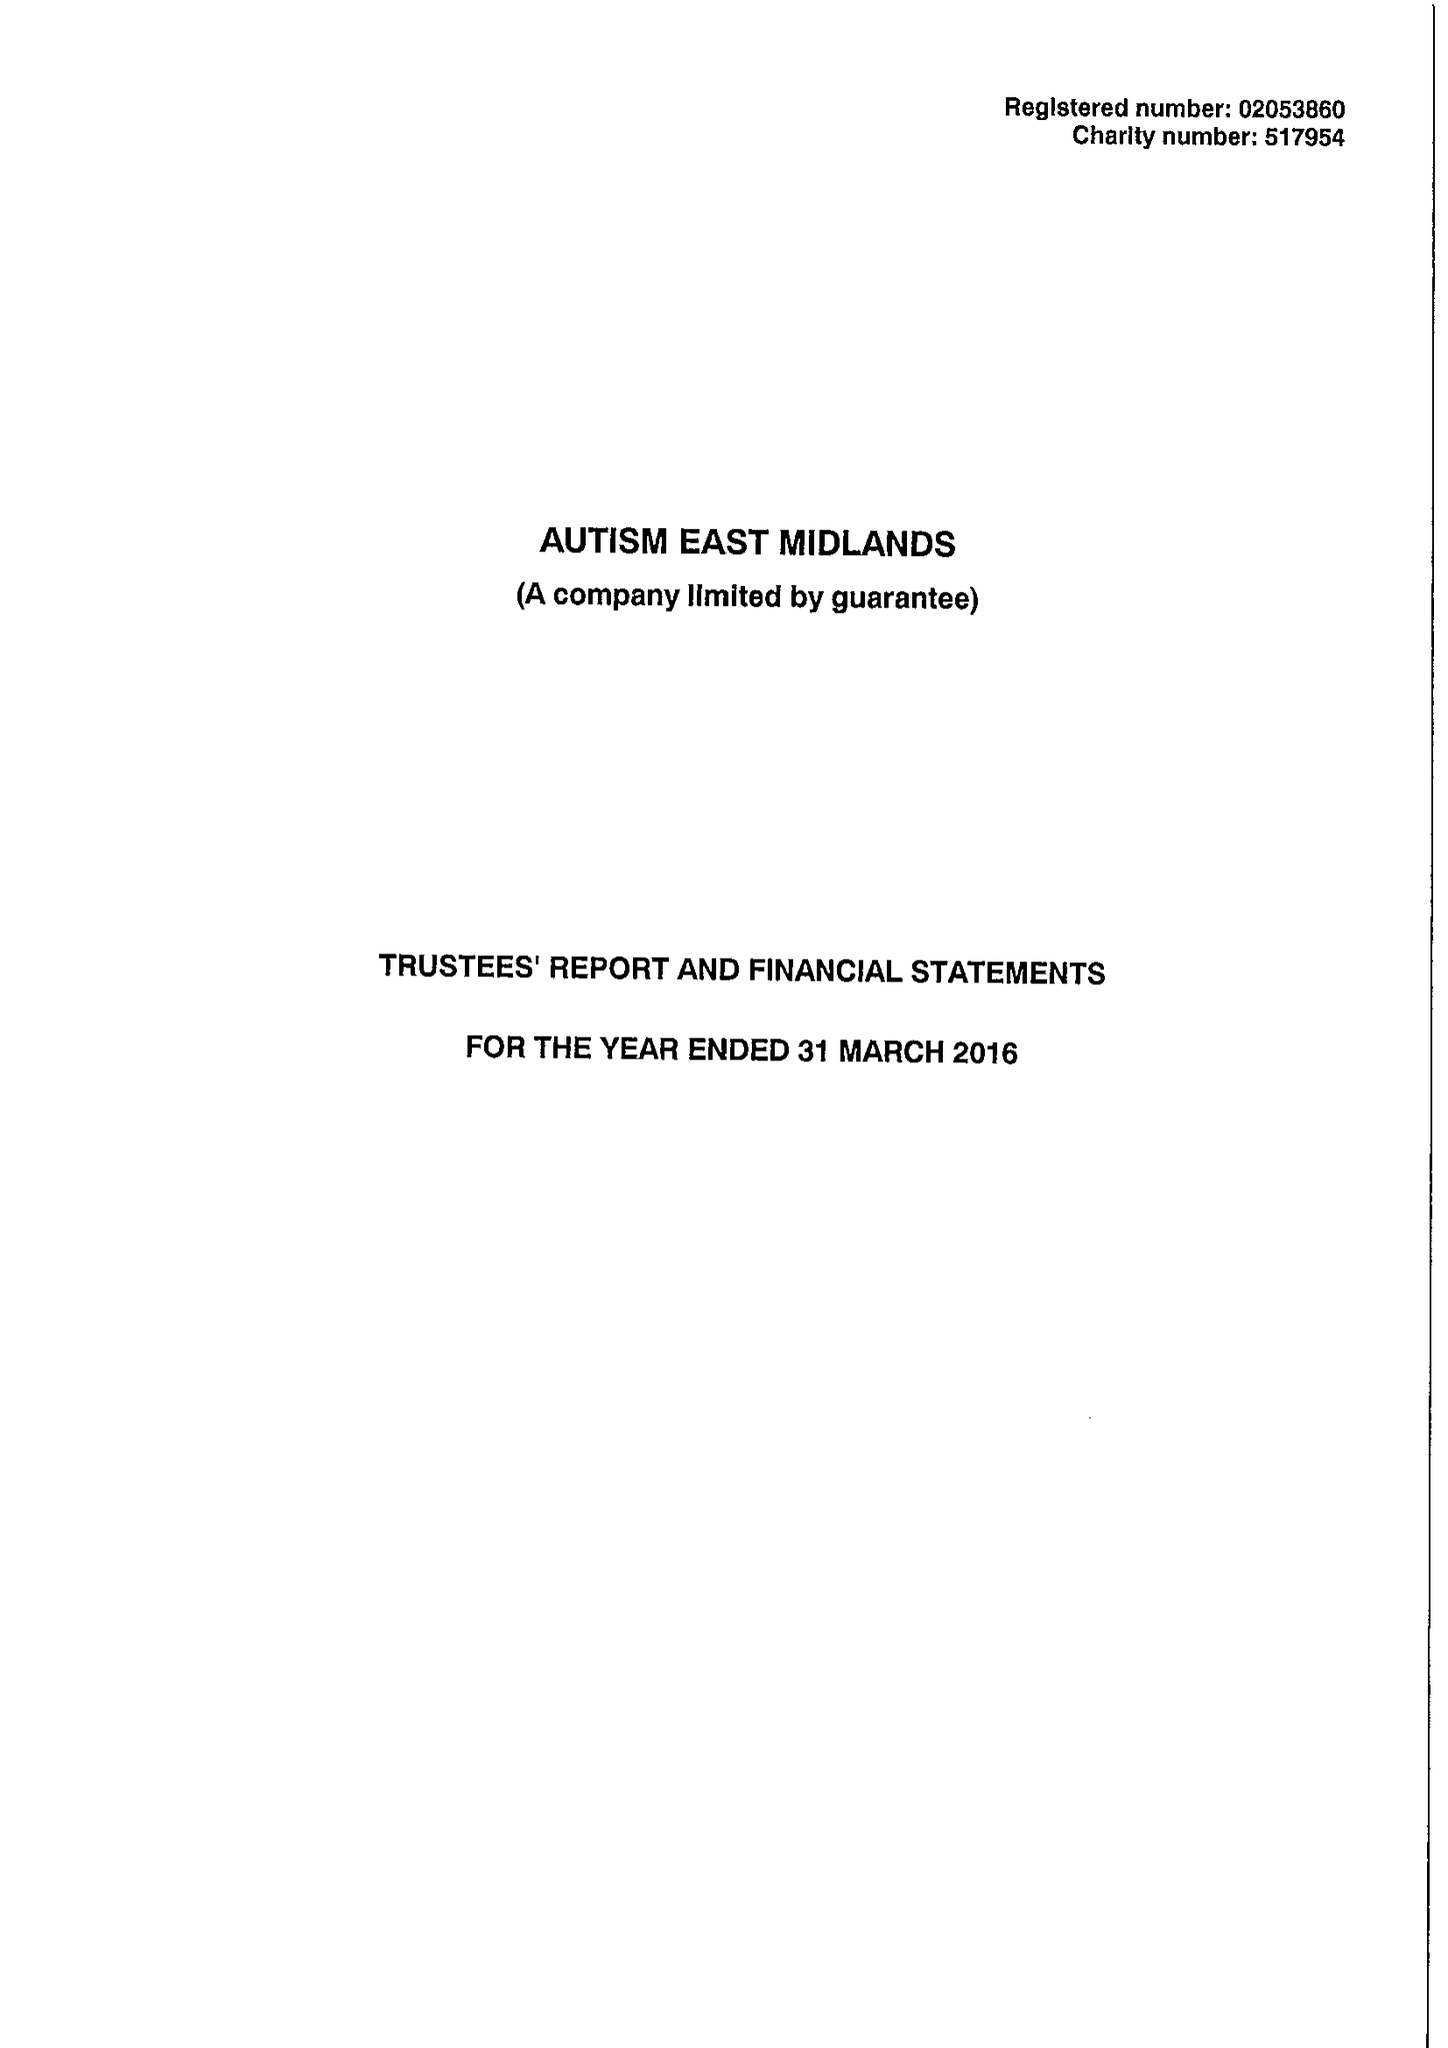What is the value for the report_date?
Answer the question using a single word or phrase. 2016-03-31 